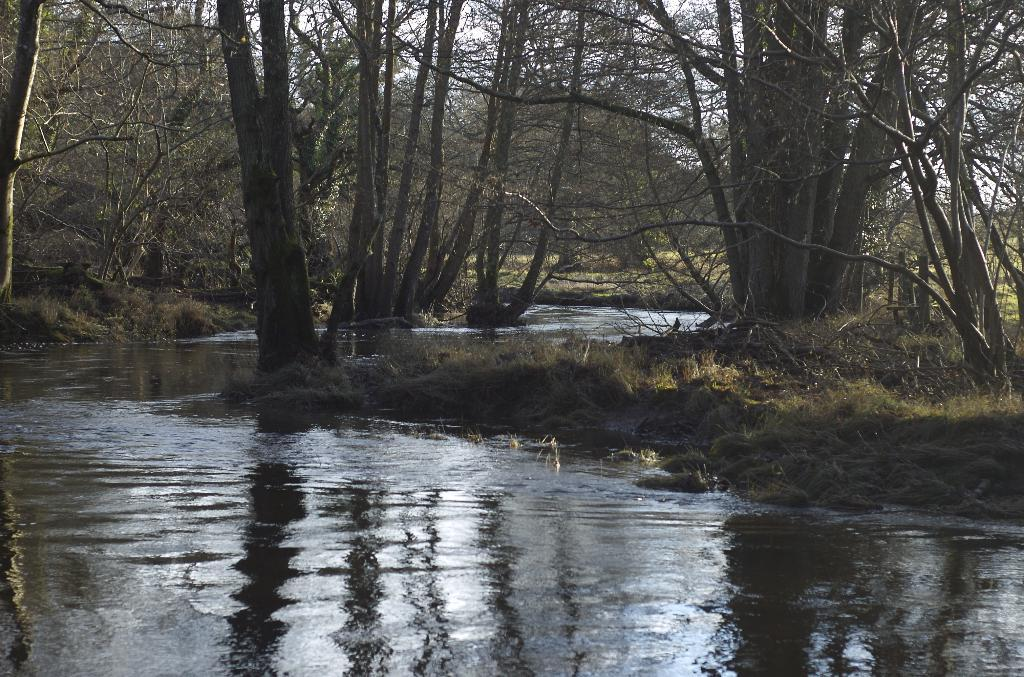What type of natural feature is visible in the image? There is a river in the image. What is the surrounding environment of the river? The river is flowing through a forest. What types of vegetation can be seen in the forest? Trees and plants are present in the forest. How is the sky depicted in the image? The sky is bright in the image. What type of celery can be seen growing in the forest in the image? There is no celery present in the image; it is a river flowing through a forest with trees and plants. How does the fork affect the flow of the river in the image? There is no fork present in the image, so it cannot affect the flow of the river. 